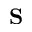Convert formula to latex. <formula><loc_0><loc_0><loc_500><loc_500>S</formula> 